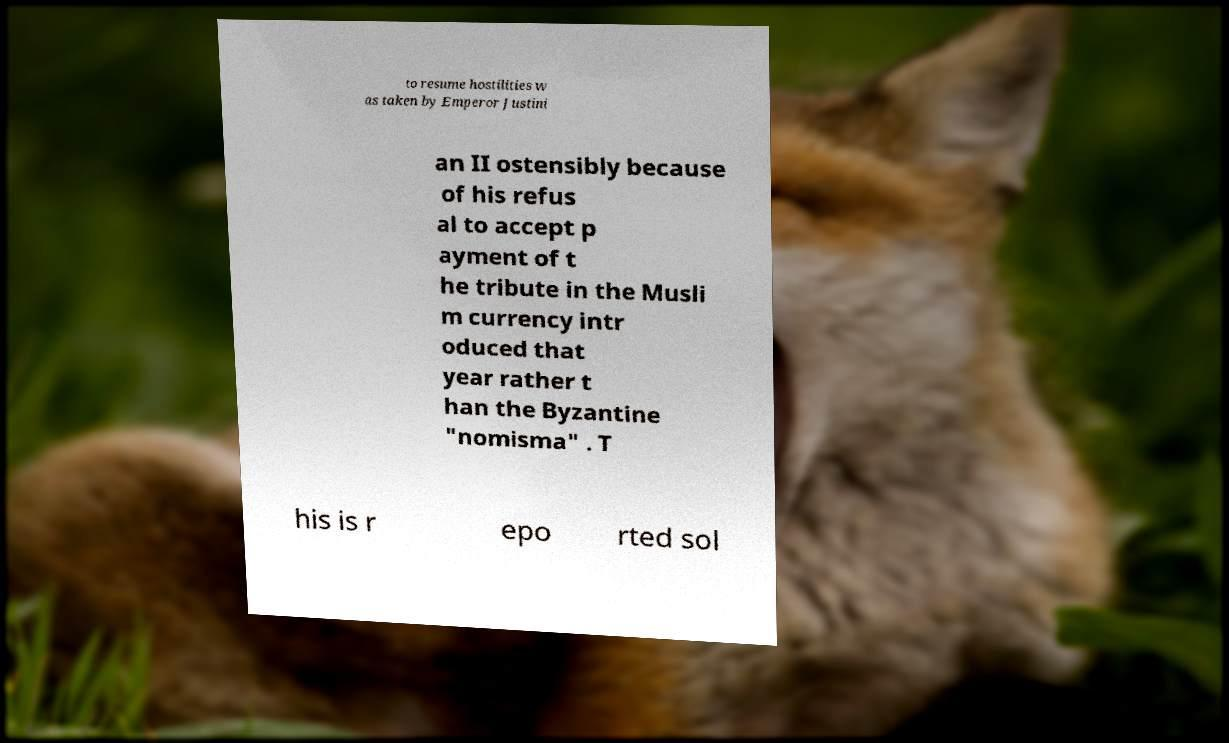Could you extract and type out the text from this image? to resume hostilities w as taken by Emperor Justini an II ostensibly because of his refus al to accept p ayment of t he tribute in the Musli m currency intr oduced that year rather t han the Byzantine "nomisma" . T his is r epo rted sol 